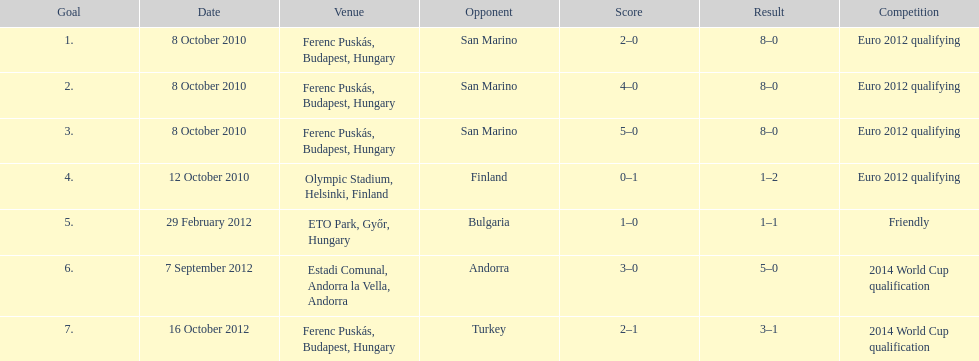What is the number of goals ádám szalai made against san marino in 2010? 3. 